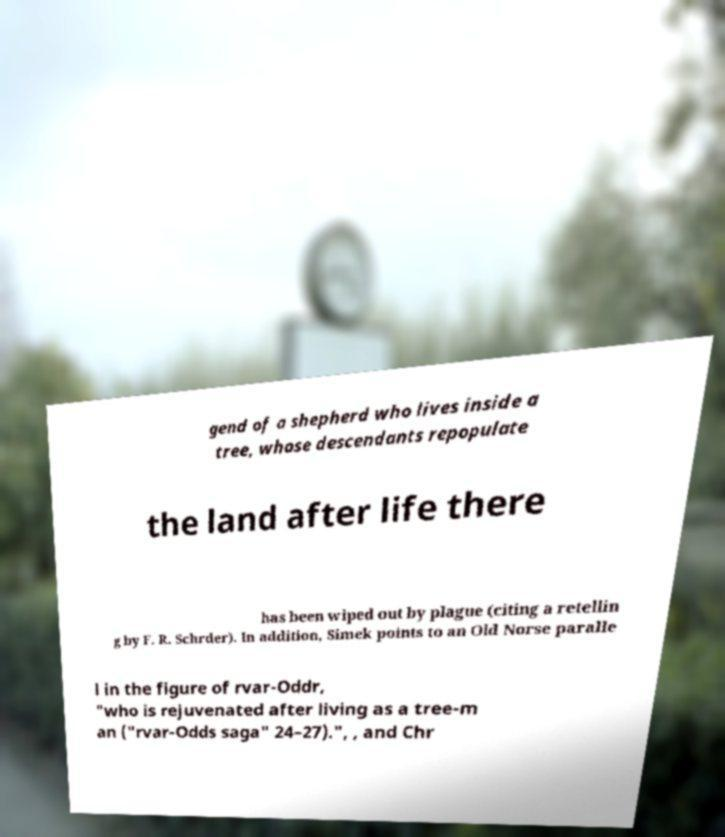Can you accurately transcribe the text from the provided image for me? gend of a shepherd who lives inside a tree, whose descendants repopulate the land after life there has been wiped out by plague (citing a retellin g by F. R. Schrder). In addition, Simek points to an Old Norse paralle l in the figure of rvar-Oddr, "who is rejuvenated after living as a tree-m an ("rvar-Odds saga" 24–27).", , and Chr 